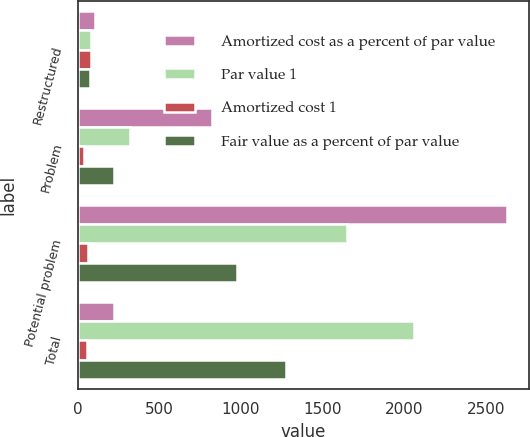Convert chart to OTSL. <chart><loc_0><loc_0><loc_500><loc_500><stacked_bar_chart><ecel><fcel>Restructured<fcel>Problem<fcel>Potential problem<fcel>Total<nl><fcel>Amortized cost as a percent of par value<fcel>107<fcel>823<fcel>2630<fcel>221<nl><fcel>Par value 1<fcel>85<fcel>321<fcel>1651<fcel>2057<nl><fcel>Amortized cost 1<fcel>79.4<fcel>39<fcel>62.8<fcel>57.8<nl><fcel>Fair value as a percent of par value<fcel>75<fcel>221<fcel>977<fcel>1273<nl></chart> 